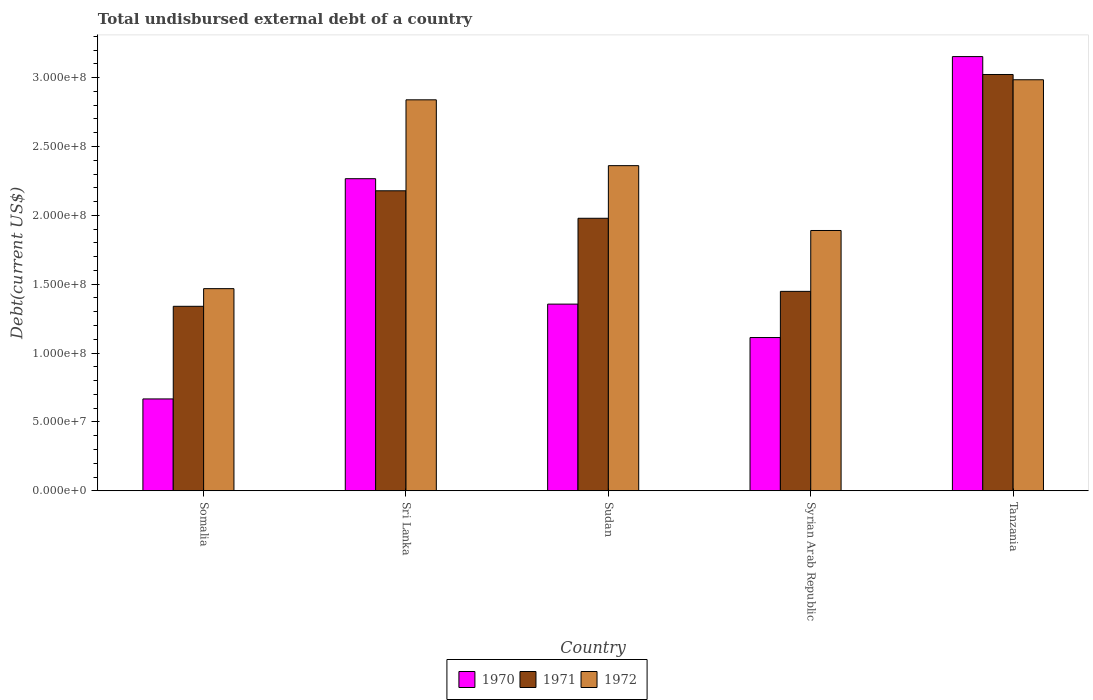How many different coloured bars are there?
Your response must be concise. 3. How many groups of bars are there?
Your answer should be very brief. 5. Are the number of bars on each tick of the X-axis equal?
Give a very brief answer. Yes. How many bars are there on the 5th tick from the left?
Keep it short and to the point. 3. What is the label of the 1st group of bars from the left?
Offer a very short reply. Somalia. What is the total undisbursed external debt in 1972 in Tanzania?
Offer a very short reply. 2.98e+08. Across all countries, what is the maximum total undisbursed external debt in 1970?
Provide a short and direct response. 3.15e+08. Across all countries, what is the minimum total undisbursed external debt in 1971?
Ensure brevity in your answer.  1.34e+08. In which country was the total undisbursed external debt in 1972 maximum?
Your answer should be compact. Tanzania. In which country was the total undisbursed external debt in 1972 minimum?
Your answer should be compact. Somalia. What is the total total undisbursed external debt in 1971 in the graph?
Provide a short and direct response. 9.97e+08. What is the difference between the total undisbursed external debt in 1971 in Somalia and that in Syrian Arab Republic?
Offer a terse response. -1.08e+07. What is the difference between the total undisbursed external debt in 1971 in Syrian Arab Republic and the total undisbursed external debt in 1972 in Tanzania?
Give a very brief answer. -1.54e+08. What is the average total undisbursed external debt in 1970 per country?
Provide a short and direct response. 1.71e+08. What is the difference between the total undisbursed external debt of/in 1972 and total undisbursed external debt of/in 1971 in Sri Lanka?
Your answer should be very brief. 6.61e+07. In how many countries, is the total undisbursed external debt in 1970 greater than 180000000 US$?
Keep it short and to the point. 2. What is the ratio of the total undisbursed external debt in 1971 in Somalia to that in Sri Lanka?
Provide a short and direct response. 0.61. Is the total undisbursed external debt in 1971 in Somalia less than that in Sudan?
Your response must be concise. Yes. Is the difference between the total undisbursed external debt in 1972 in Somalia and Sudan greater than the difference between the total undisbursed external debt in 1971 in Somalia and Sudan?
Provide a succinct answer. No. What is the difference between the highest and the second highest total undisbursed external debt in 1972?
Provide a succinct answer. 1.46e+07. What is the difference between the highest and the lowest total undisbursed external debt in 1972?
Provide a succinct answer. 1.52e+08. In how many countries, is the total undisbursed external debt in 1971 greater than the average total undisbursed external debt in 1971 taken over all countries?
Give a very brief answer. 2. Is the sum of the total undisbursed external debt in 1971 in Somalia and Sri Lanka greater than the maximum total undisbursed external debt in 1972 across all countries?
Your answer should be compact. Yes. What does the 3rd bar from the left in Sudan represents?
Offer a terse response. 1972. What does the 3rd bar from the right in Sudan represents?
Make the answer very short. 1970. Is it the case that in every country, the sum of the total undisbursed external debt in 1972 and total undisbursed external debt in 1971 is greater than the total undisbursed external debt in 1970?
Your response must be concise. Yes. Are all the bars in the graph horizontal?
Your response must be concise. No. How many countries are there in the graph?
Your response must be concise. 5. Are the values on the major ticks of Y-axis written in scientific E-notation?
Offer a terse response. Yes. How are the legend labels stacked?
Make the answer very short. Horizontal. What is the title of the graph?
Your answer should be very brief. Total undisbursed external debt of a country. What is the label or title of the Y-axis?
Your answer should be compact. Debt(current US$). What is the Debt(current US$) in 1970 in Somalia?
Offer a very short reply. 6.67e+07. What is the Debt(current US$) in 1971 in Somalia?
Make the answer very short. 1.34e+08. What is the Debt(current US$) in 1972 in Somalia?
Provide a short and direct response. 1.47e+08. What is the Debt(current US$) of 1970 in Sri Lanka?
Keep it short and to the point. 2.27e+08. What is the Debt(current US$) of 1971 in Sri Lanka?
Your response must be concise. 2.18e+08. What is the Debt(current US$) of 1972 in Sri Lanka?
Offer a very short reply. 2.84e+08. What is the Debt(current US$) of 1970 in Sudan?
Offer a terse response. 1.36e+08. What is the Debt(current US$) in 1971 in Sudan?
Provide a short and direct response. 1.98e+08. What is the Debt(current US$) in 1972 in Sudan?
Provide a short and direct response. 2.36e+08. What is the Debt(current US$) of 1970 in Syrian Arab Republic?
Keep it short and to the point. 1.11e+08. What is the Debt(current US$) of 1971 in Syrian Arab Republic?
Ensure brevity in your answer.  1.45e+08. What is the Debt(current US$) in 1972 in Syrian Arab Republic?
Provide a short and direct response. 1.89e+08. What is the Debt(current US$) in 1970 in Tanzania?
Keep it short and to the point. 3.15e+08. What is the Debt(current US$) of 1971 in Tanzania?
Your response must be concise. 3.02e+08. What is the Debt(current US$) in 1972 in Tanzania?
Your response must be concise. 2.98e+08. Across all countries, what is the maximum Debt(current US$) in 1970?
Offer a very short reply. 3.15e+08. Across all countries, what is the maximum Debt(current US$) in 1971?
Provide a succinct answer. 3.02e+08. Across all countries, what is the maximum Debt(current US$) in 1972?
Keep it short and to the point. 2.98e+08. Across all countries, what is the minimum Debt(current US$) of 1970?
Provide a short and direct response. 6.67e+07. Across all countries, what is the minimum Debt(current US$) of 1971?
Provide a short and direct response. 1.34e+08. Across all countries, what is the minimum Debt(current US$) in 1972?
Provide a succinct answer. 1.47e+08. What is the total Debt(current US$) of 1970 in the graph?
Make the answer very short. 8.55e+08. What is the total Debt(current US$) of 1971 in the graph?
Make the answer very short. 9.97e+08. What is the total Debt(current US$) in 1972 in the graph?
Your answer should be very brief. 1.15e+09. What is the difference between the Debt(current US$) in 1970 in Somalia and that in Sri Lanka?
Your answer should be compact. -1.60e+08. What is the difference between the Debt(current US$) of 1971 in Somalia and that in Sri Lanka?
Offer a terse response. -8.39e+07. What is the difference between the Debt(current US$) in 1972 in Somalia and that in Sri Lanka?
Your answer should be very brief. -1.37e+08. What is the difference between the Debt(current US$) of 1970 in Somalia and that in Sudan?
Offer a terse response. -6.88e+07. What is the difference between the Debt(current US$) of 1971 in Somalia and that in Sudan?
Give a very brief answer. -6.39e+07. What is the difference between the Debt(current US$) in 1972 in Somalia and that in Sudan?
Offer a very short reply. -8.93e+07. What is the difference between the Debt(current US$) in 1970 in Somalia and that in Syrian Arab Republic?
Give a very brief answer. -4.46e+07. What is the difference between the Debt(current US$) of 1971 in Somalia and that in Syrian Arab Republic?
Offer a very short reply. -1.08e+07. What is the difference between the Debt(current US$) of 1972 in Somalia and that in Syrian Arab Republic?
Your response must be concise. -4.22e+07. What is the difference between the Debt(current US$) in 1970 in Somalia and that in Tanzania?
Offer a very short reply. -2.49e+08. What is the difference between the Debt(current US$) of 1971 in Somalia and that in Tanzania?
Offer a terse response. -1.68e+08. What is the difference between the Debt(current US$) of 1972 in Somalia and that in Tanzania?
Give a very brief answer. -1.52e+08. What is the difference between the Debt(current US$) of 1970 in Sri Lanka and that in Sudan?
Make the answer very short. 9.11e+07. What is the difference between the Debt(current US$) in 1971 in Sri Lanka and that in Sudan?
Give a very brief answer. 2.00e+07. What is the difference between the Debt(current US$) of 1972 in Sri Lanka and that in Sudan?
Your answer should be compact. 4.78e+07. What is the difference between the Debt(current US$) in 1970 in Sri Lanka and that in Syrian Arab Republic?
Your answer should be compact. 1.15e+08. What is the difference between the Debt(current US$) of 1971 in Sri Lanka and that in Syrian Arab Republic?
Your answer should be very brief. 7.30e+07. What is the difference between the Debt(current US$) of 1972 in Sri Lanka and that in Syrian Arab Republic?
Your answer should be very brief. 9.49e+07. What is the difference between the Debt(current US$) in 1970 in Sri Lanka and that in Tanzania?
Make the answer very short. -8.87e+07. What is the difference between the Debt(current US$) in 1971 in Sri Lanka and that in Tanzania?
Your response must be concise. -8.44e+07. What is the difference between the Debt(current US$) in 1972 in Sri Lanka and that in Tanzania?
Offer a very short reply. -1.46e+07. What is the difference between the Debt(current US$) in 1970 in Sudan and that in Syrian Arab Republic?
Ensure brevity in your answer.  2.43e+07. What is the difference between the Debt(current US$) of 1971 in Sudan and that in Syrian Arab Republic?
Ensure brevity in your answer.  5.31e+07. What is the difference between the Debt(current US$) in 1972 in Sudan and that in Syrian Arab Republic?
Keep it short and to the point. 4.71e+07. What is the difference between the Debt(current US$) of 1970 in Sudan and that in Tanzania?
Your response must be concise. -1.80e+08. What is the difference between the Debt(current US$) in 1971 in Sudan and that in Tanzania?
Keep it short and to the point. -1.04e+08. What is the difference between the Debt(current US$) of 1972 in Sudan and that in Tanzania?
Give a very brief answer. -6.24e+07. What is the difference between the Debt(current US$) of 1970 in Syrian Arab Republic and that in Tanzania?
Give a very brief answer. -2.04e+08. What is the difference between the Debt(current US$) of 1971 in Syrian Arab Republic and that in Tanzania?
Make the answer very short. -1.57e+08. What is the difference between the Debt(current US$) of 1972 in Syrian Arab Republic and that in Tanzania?
Keep it short and to the point. -1.09e+08. What is the difference between the Debt(current US$) of 1970 in Somalia and the Debt(current US$) of 1971 in Sri Lanka?
Provide a succinct answer. -1.51e+08. What is the difference between the Debt(current US$) in 1970 in Somalia and the Debt(current US$) in 1972 in Sri Lanka?
Offer a terse response. -2.17e+08. What is the difference between the Debt(current US$) of 1971 in Somalia and the Debt(current US$) of 1972 in Sri Lanka?
Your answer should be compact. -1.50e+08. What is the difference between the Debt(current US$) of 1970 in Somalia and the Debt(current US$) of 1971 in Sudan?
Ensure brevity in your answer.  -1.31e+08. What is the difference between the Debt(current US$) of 1970 in Somalia and the Debt(current US$) of 1972 in Sudan?
Ensure brevity in your answer.  -1.69e+08. What is the difference between the Debt(current US$) in 1971 in Somalia and the Debt(current US$) in 1972 in Sudan?
Your response must be concise. -1.02e+08. What is the difference between the Debt(current US$) of 1970 in Somalia and the Debt(current US$) of 1971 in Syrian Arab Republic?
Provide a succinct answer. -7.81e+07. What is the difference between the Debt(current US$) in 1970 in Somalia and the Debt(current US$) in 1972 in Syrian Arab Republic?
Offer a very short reply. -1.22e+08. What is the difference between the Debt(current US$) of 1971 in Somalia and the Debt(current US$) of 1972 in Syrian Arab Republic?
Offer a terse response. -5.50e+07. What is the difference between the Debt(current US$) of 1970 in Somalia and the Debt(current US$) of 1971 in Tanzania?
Offer a very short reply. -2.36e+08. What is the difference between the Debt(current US$) of 1970 in Somalia and the Debt(current US$) of 1972 in Tanzania?
Provide a short and direct response. -2.32e+08. What is the difference between the Debt(current US$) of 1971 in Somalia and the Debt(current US$) of 1972 in Tanzania?
Offer a terse response. -1.65e+08. What is the difference between the Debt(current US$) in 1970 in Sri Lanka and the Debt(current US$) in 1971 in Sudan?
Your answer should be compact. 2.87e+07. What is the difference between the Debt(current US$) of 1970 in Sri Lanka and the Debt(current US$) of 1972 in Sudan?
Give a very brief answer. -9.47e+06. What is the difference between the Debt(current US$) in 1971 in Sri Lanka and the Debt(current US$) in 1972 in Sudan?
Provide a short and direct response. -1.82e+07. What is the difference between the Debt(current US$) of 1970 in Sri Lanka and the Debt(current US$) of 1971 in Syrian Arab Republic?
Provide a short and direct response. 8.18e+07. What is the difference between the Debt(current US$) in 1970 in Sri Lanka and the Debt(current US$) in 1972 in Syrian Arab Republic?
Give a very brief answer. 3.76e+07. What is the difference between the Debt(current US$) of 1971 in Sri Lanka and the Debt(current US$) of 1972 in Syrian Arab Republic?
Provide a short and direct response. 2.88e+07. What is the difference between the Debt(current US$) of 1970 in Sri Lanka and the Debt(current US$) of 1971 in Tanzania?
Make the answer very short. -7.57e+07. What is the difference between the Debt(current US$) in 1970 in Sri Lanka and the Debt(current US$) in 1972 in Tanzania?
Your response must be concise. -7.18e+07. What is the difference between the Debt(current US$) in 1971 in Sri Lanka and the Debt(current US$) in 1972 in Tanzania?
Ensure brevity in your answer.  -8.06e+07. What is the difference between the Debt(current US$) of 1970 in Sudan and the Debt(current US$) of 1971 in Syrian Arab Republic?
Offer a very short reply. -9.26e+06. What is the difference between the Debt(current US$) of 1970 in Sudan and the Debt(current US$) of 1972 in Syrian Arab Republic?
Make the answer very short. -5.35e+07. What is the difference between the Debt(current US$) in 1971 in Sudan and the Debt(current US$) in 1972 in Syrian Arab Republic?
Ensure brevity in your answer.  8.87e+06. What is the difference between the Debt(current US$) in 1970 in Sudan and the Debt(current US$) in 1971 in Tanzania?
Provide a short and direct response. -1.67e+08. What is the difference between the Debt(current US$) in 1970 in Sudan and the Debt(current US$) in 1972 in Tanzania?
Offer a very short reply. -1.63e+08. What is the difference between the Debt(current US$) in 1971 in Sudan and the Debt(current US$) in 1972 in Tanzania?
Your response must be concise. -1.01e+08. What is the difference between the Debt(current US$) of 1970 in Syrian Arab Republic and the Debt(current US$) of 1971 in Tanzania?
Make the answer very short. -1.91e+08. What is the difference between the Debt(current US$) of 1970 in Syrian Arab Republic and the Debt(current US$) of 1972 in Tanzania?
Provide a short and direct response. -1.87e+08. What is the difference between the Debt(current US$) of 1971 in Syrian Arab Republic and the Debt(current US$) of 1972 in Tanzania?
Offer a very short reply. -1.54e+08. What is the average Debt(current US$) of 1970 per country?
Provide a short and direct response. 1.71e+08. What is the average Debt(current US$) in 1971 per country?
Your answer should be very brief. 1.99e+08. What is the average Debt(current US$) in 1972 per country?
Make the answer very short. 2.31e+08. What is the difference between the Debt(current US$) of 1970 and Debt(current US$) of 1971 in Somalia?
Offer a very short reply. -6.73e+07. What is the difference between the Debt(current US$) of 1970 and Debt(current US$) of 1972 in Somalia?
Your answer should be very brief. -8.01e+07. What is the difference between the Debt(current US$) in 1971 and Debt(current US$) in 1972 in Somalia?
Keep it short and to the point. -1.28e+07. What is the difference between the Debt(current US$) in 1970 and Debt(current US$) in 1971 in Sri Lanka?
Provide a short and direct response. 8.78e+06. What is the difference between the Debt(current US$) of 1970 and Debt(current US$) of 1972 in Sri Lanka?
Your answer should be compact. -5.73e+07. What is the difference between the Debt(current US$) in 1971 and Debt(current US$) in 1972 in Sri Lanka?
Your response must be concise. -6.61e+07. What is the difference between the Debt(current US$) of 1970 and Debt(current US$) of 1971 in Sudan?
Your response must be concise. -6.23e+07. What is the difference between the Debt(current US$) in 1970 and Debt(current US$) in 1972 in Sudan?
Keep it short and to the point. -1.01e+08. What is the difference between the Debt(current US$) of 1971 and Debt(current US$) of 1972 in Sudan?
Offer a very short reply. -3.82e+07. What is the difference between the Debt(current US$) in 1970 and Debt(current US$) in 1971 in Syrian Arab Republic?
Keep it short and to the point. -3.35e+07. What is the difference between the Debt(current US$) in 1970 and Debt(current US$) in 1972 in Syrian Arab Republic?
Your answer should be very brief. -7.77e+07. What is the difference between the Debt(current US$) of 1971 and Debt(current US$) of 1972 in Syrian Arab Republic?
Your answer should be very brief. -4.42e+07. What is the difference between the Debt(current US$) in 1970 and Debt(current US$) in 1971 in Tanzania?
Offer a terse response. 1.30e+07. What is the difference between the Debt(current US$) of 1970 and Debt(current US$) of 1972 in Tanzania?
Offer a very short reply. 1.68e+07. What is the difference between the Debt(current US$) of 1971 and Debt(current US$) of 1972 in Tanzania?
Provide a succinct answer. 3.82e+06. What is the ratio of the Debt(current US$) of 1970 in Somalia to that in Sri Lanka?
Ensure brevity in your answer.  0.29. What is the ratio of the Debt(current US$) of 1971 in Somalia to that in Sri Lanka?
Provide a short and direct response. 0.61. What is the ratio of the Debt(current US$) in 1972 in Somalia to that in Sri Lanka?
Make the answer very short. 0.52. What is the ratio of the Debt(current US$) of 1970 in Somalia to that in Sudan?
Provide a short and direct response. 0.49. What is the ratio of the Debt(current US$) in 1971 in Somalia to that in Sudan?
Make the answer very short. 0.68. What is the ratio of the Debt(current US$) in 1972 in Somalia to that in Sudan?
Provide a succinct answer. 0.62. What is the ratio of the Debt(current US$) in 1970 in Somalia to that in Syrian Arab Republic?
Keep it short and to the point. 0.6. What is the ratio of the Debt(current US$) of 1971 in Somalia to that in Syrian Arab Republic?
Provide a short and direct response. 0.93. What is the ratio of the Debt(current US$) in 1972 in Somalia to that in Syrian Arab Republic?
Offer a very short reply. 0.78. What is the ratio of the Debt(current US$) of 1970 in Somalia to that in Tanzania?
Make the answer very short. 0.21. What is the ratio of the Debt(current US$) of 1971 in Somalia to that in Tanzania?
Offer a terse response. 0.44. What is the ratio of the Debt(current US$) in 1972 in Somalia to that in Tanzania?
Your answer should be compact. 0.49. What is the ratio of the Debt(current US$) of 1970 in Sri Lanka to that in Sudan?
Your answer should be compact. 1.67. What is the ratio of the Debt(current US$) in 1971 in Sri Lanka to that in Sudan?
Ensure brevity in your answer.  1.1. What is the ratio of the Debt(current US$) in 1972 in Sri Lanka to that in Sudan?
Offer a very short reply. 1.2. What is the ratio of the Debt(current US$) in 1970 in Sri Lanka to that in Syrian Arab Republic?
Your answer should be compact. 2.04. What is the ratio of the Debt(current US$) in 1971 in Sri Lanka to that in Syrian Arab Republic?
Your response must be concise. 1.5. What is the ratio of the Debt(current US$) of 1972 in Sri Lanka to that in Syrian Arab Republic?
Give a very brief answer. 1.5. What is the ratio of the Debt(current US$) of 1970 in Sri Lanka to that in Tanzania?
Provide a short and direct response. 0.72. What is the ratio of the Debt(current US$) of 1971 in Sri Lanka to that in Tanzania?
Offer a terse response. 0.72. What is the ratio of the Debt(current US$) of 1972 in Sri Lanka to that in Tanzania?
Provide a succinct answer. 0.95. What is the ratio of the Debt(current US$) in 1970 in Sudan to that in Syrian Arab Republic?
Your answer should be compact. 1.22. What is the ratio of the Debt(current US$) of 1971 in Sudan to that in Syrian Arab Republic?
Your response must be concise. 1.37. What is the ratio of the Debt(current US$) in 1972 in Sudan to that in Syrian Arab Republic?
Give a very brief answer. 1.25. What is the ratio of the Debt(current US$) of 1970 in Sudan to that in Tanzania?
Offer a terse response. 0.43. What is the ratio of the Debt(current US$) in 1971 in Sudan to that in Tanzania?
Make the answer very short. 0.65. What is the ratio of the Debt(current US$) of 1972 in Sudan to that in Tanzania?
Provide a short and direct response. 0.79. What is the ratio of the Debt(current US$) in 1970 in Syrian Arab Republic to that in Tanzania?
Offer a very short reply. 0.35. What is the ratio of the Debt(current US$) in 1971 in Syrian Arab Republic to that in Tanzania?
Offer a very short reply. 0.48. What is the ratio of the Debt(current US$) in 1972 in Syrian Arab Republic to that in Tanzania?
Make the answer very short. 0.63. What is the difference between the highest and the second highest Debt(current US$) in 1970?
Provide a succinct answer. 8.87e+07. What is the difference between the highest and the second highest Debt(current US$) in 1971?
Provide a succinct answer. 8.44e+07. What is the difference between the highest and the second highest Debt(current US$) of 1972?
Your response must be concise. 1.46e+07. What is the difference between the highest and the lowest Debt(current US$) of 1970?
Offer a very short reply. 2.49e+08. What is the difference between the highest and the lowest Debt(current US$) of 1971?
Offer a very short reply. 1.68e+08. What is the difference between the highest and the lowest Debt(current US$) in 1972?
Provide a succinct answer. 1.52e+08. 